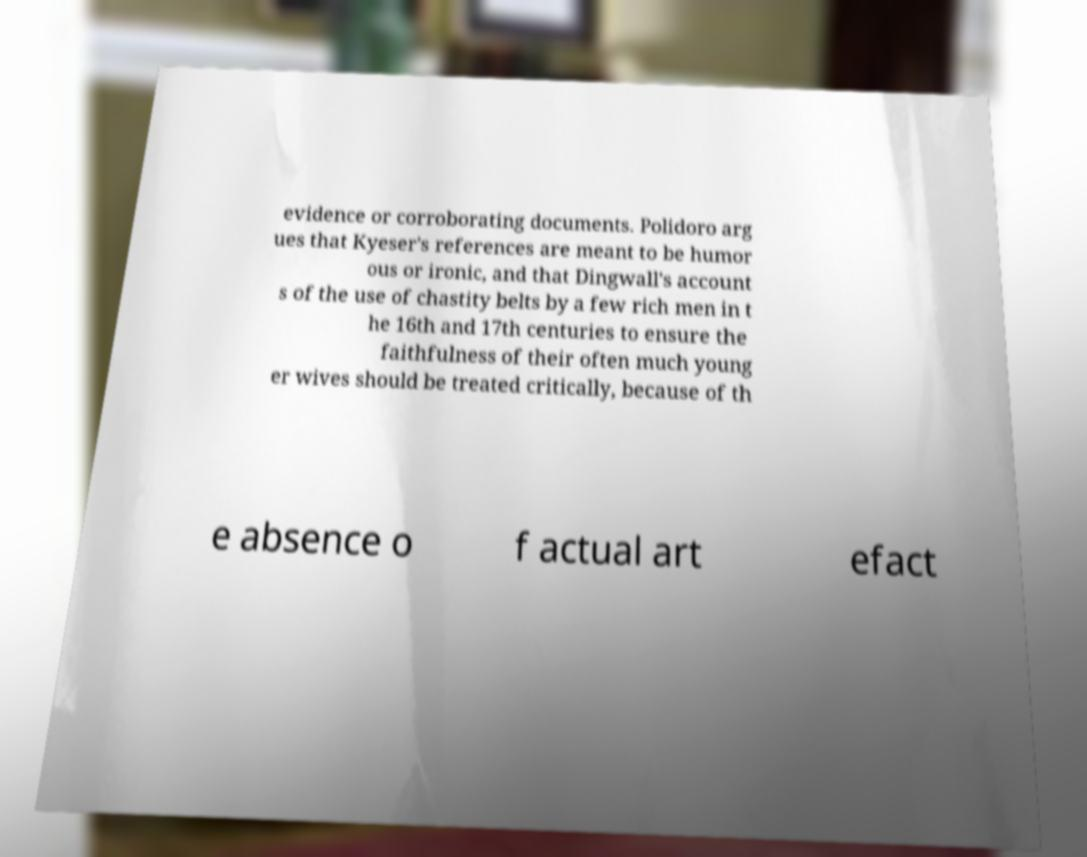What messages or text are displayed in this image? I need them in a readable, typed format. evidence or corroborating documents. Polidoro arg ues that Kyeser's references are meant to be humor ous or ironic, and that Dingwall's account s of the use of chastity belts by a few rich men in t he 16th and 17th centuries to ensure the faithfulness of their often much young er wives should be treated critically, because of th e absence o f actual art efact 